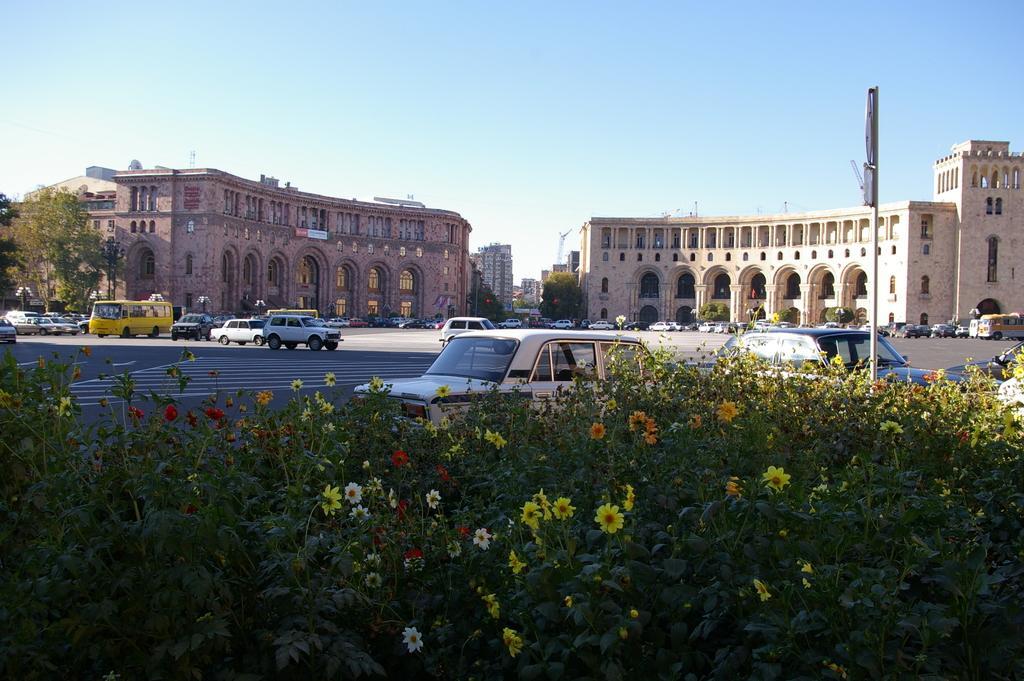Describe this image in one or two sentences. In this picture we can see the sky and it seems like a sunny day. In the background we can see the buildings and trees. We can see vehicles on the road. On the right side of the picture we can see a board and a pole. At the bottom portion of the picture we can see the colorful flowers and plants. 